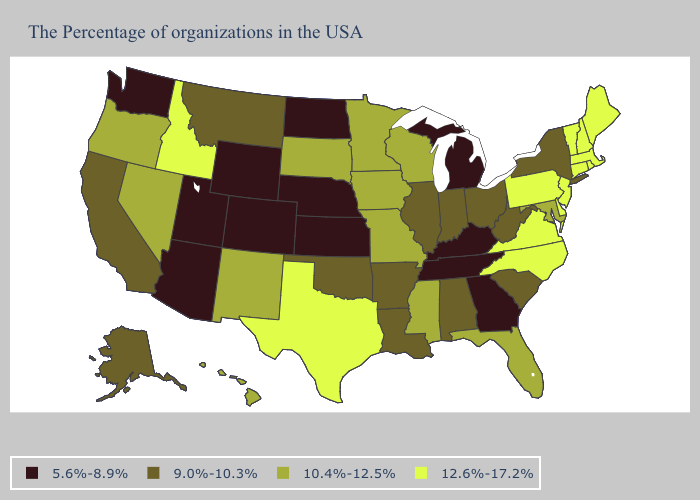Among the states that border South Carolina , which have the highest value?
Give a very brief answer. North Carolina. Does Kentucky have the highest value in the USA?
Give a very brief answer. No. Name the states that have a value in the range 5.6%-8.9%?
Write a very short answer. Georgia, Michigan, Kentucky, Tennessee, Kansas, Nebraska, North Dakota, Wyoming, Colorado, Utah, Arizona, Washington. Which states hav the highest value in the MidWest?
Short answer required. Wisconsin, Missouri, Minnesota, Iowa, South Dakota. What is the highest value in the USA?
Write a very short answer. 12.6%-17.2%. What is the value of South Dakota?
Answer briefly. 10.4%-12.5%. What is the value of California?
Quick response, please. 9.0%-10.3%. What is the highest value in the USA?
Give a very brief answer. 12.6%-17.2%. Name the states that have a value in the range 9.0%-10.3%?
Write a very short answer. New York, South Carolina, West Virginia, Ohio, Indiana, Alabama, Illinois, Louisiana, Arkansas, Oklahoma, Montana, California, Alaska. Which states have the lowest value in the South?
Short answer required. Georgia, Kentucky, Tennessee. Does South Dakota have a higher value than Colorado?
Be succinct. Yes. What is the value of Delaware?
Write a very short answer. 12.6%-17.2%. Name the states that have a value in the range 5.6%-8.9%?
Be succinct. Georgia, Michigan, Kentucky, Tennessee, Kansas, Nebraska, North Dakota, Wyoming, Colorado, Utah, Arizona, Washington. How many symbols are there in the legend?
Write a very short answer. 4. What is the lowest value in the USA?
Write a very short answer. 5.6%-8.9%. 